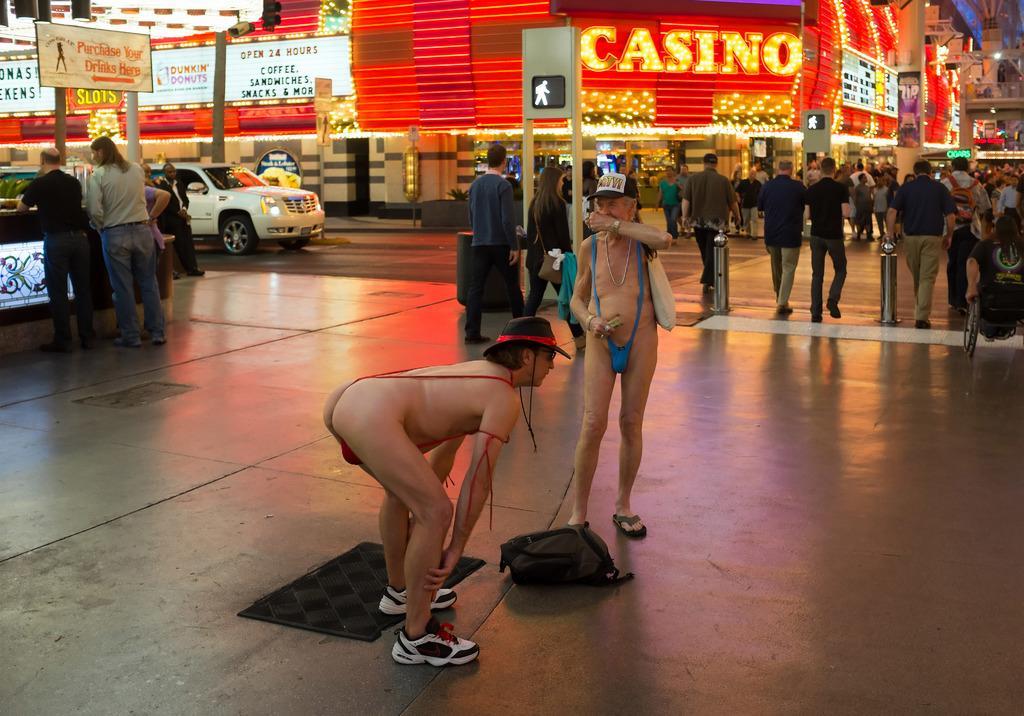How would you summarize this image in a sentence or two? In this image there are people, boarded, buildings, vehicle, store, lights and objects. Something is written on the boards. Among them few people are walking. 